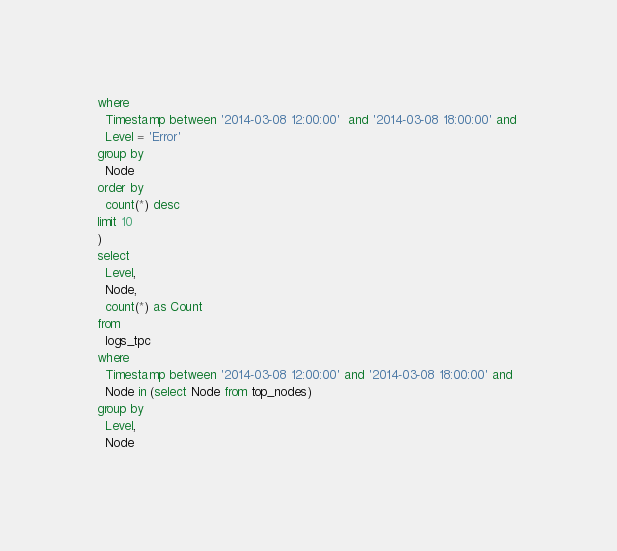<code> <loc_0><loc_0><loc_500><loc_500><_SQL_>where
  Timestamp between '2014-03-08 12:00:00'  and '2014-03-08 18:00:00' and 
  Level = 'Error'
group by 
  Node
order by
  count(*) desc
limit 10
)
select
  Level,
  Node,
  count(*) as Count
from
  logs_tpc
where
  Timestamp between '2014-03-08 12:00:00' and '2014-03-08 18:00:00' and 
  Node in (select Node from top_nodes)
group by 
  Level,
  Node</code> 